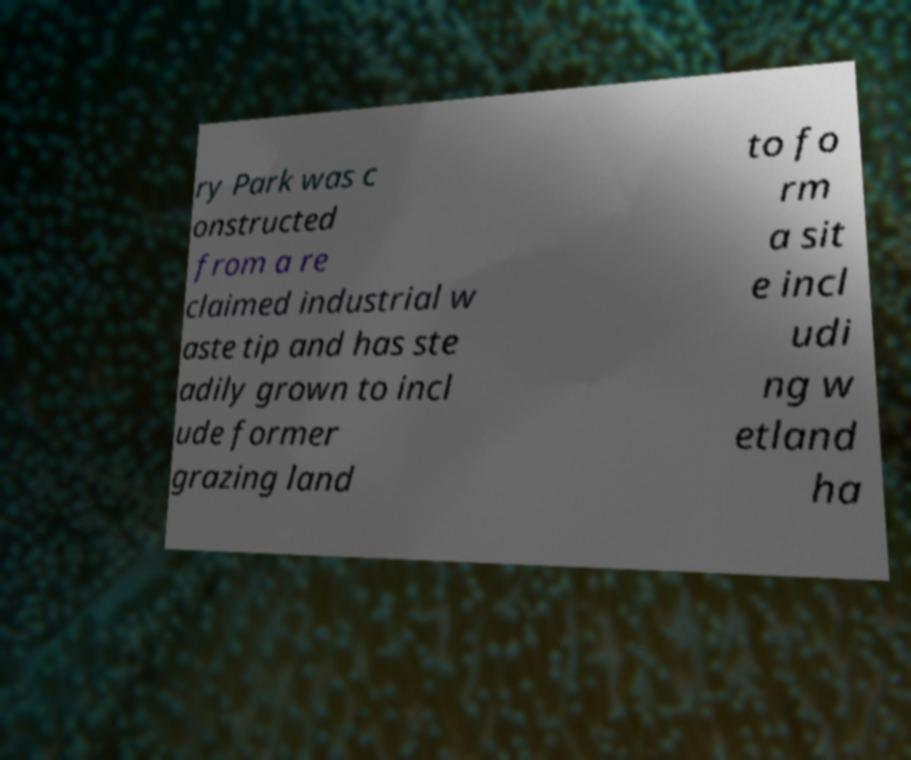Can you read and provide the text displayed in the image?This photo seems to have some interesting text. Can you extract and type it out for me? ry Park was c onstructed from a re claimed industrial w aste tip and has ste adily grown to incl ude former grazing land to fo rm a sit e incl udi ng w etland ha 